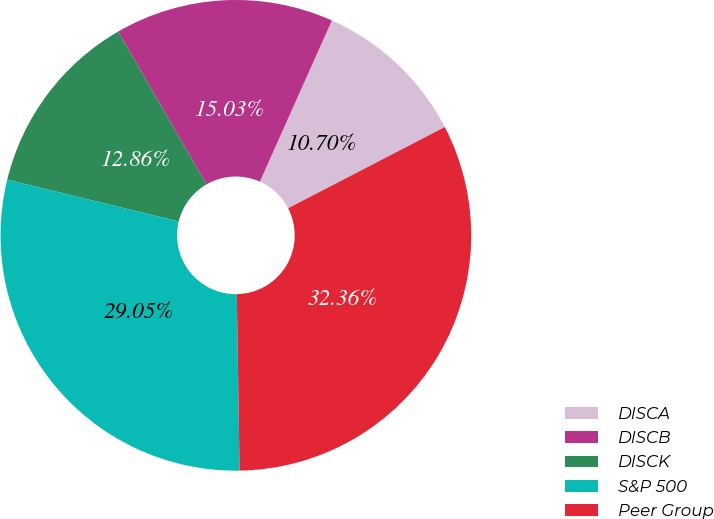Convert chart to OTSL. <chart><loc_0><loc_0><loc_500><loc_500><pie_chart><fcel>DISCA<fcel>DISCB<fcel>DISCK<fcel>S&P 500<fcel>Peer Group<nl><fcel>10.7%<fcel>15.03%<fcel>12.86%<fcel>29.05%<fcel>32.36%<nl></chart> 